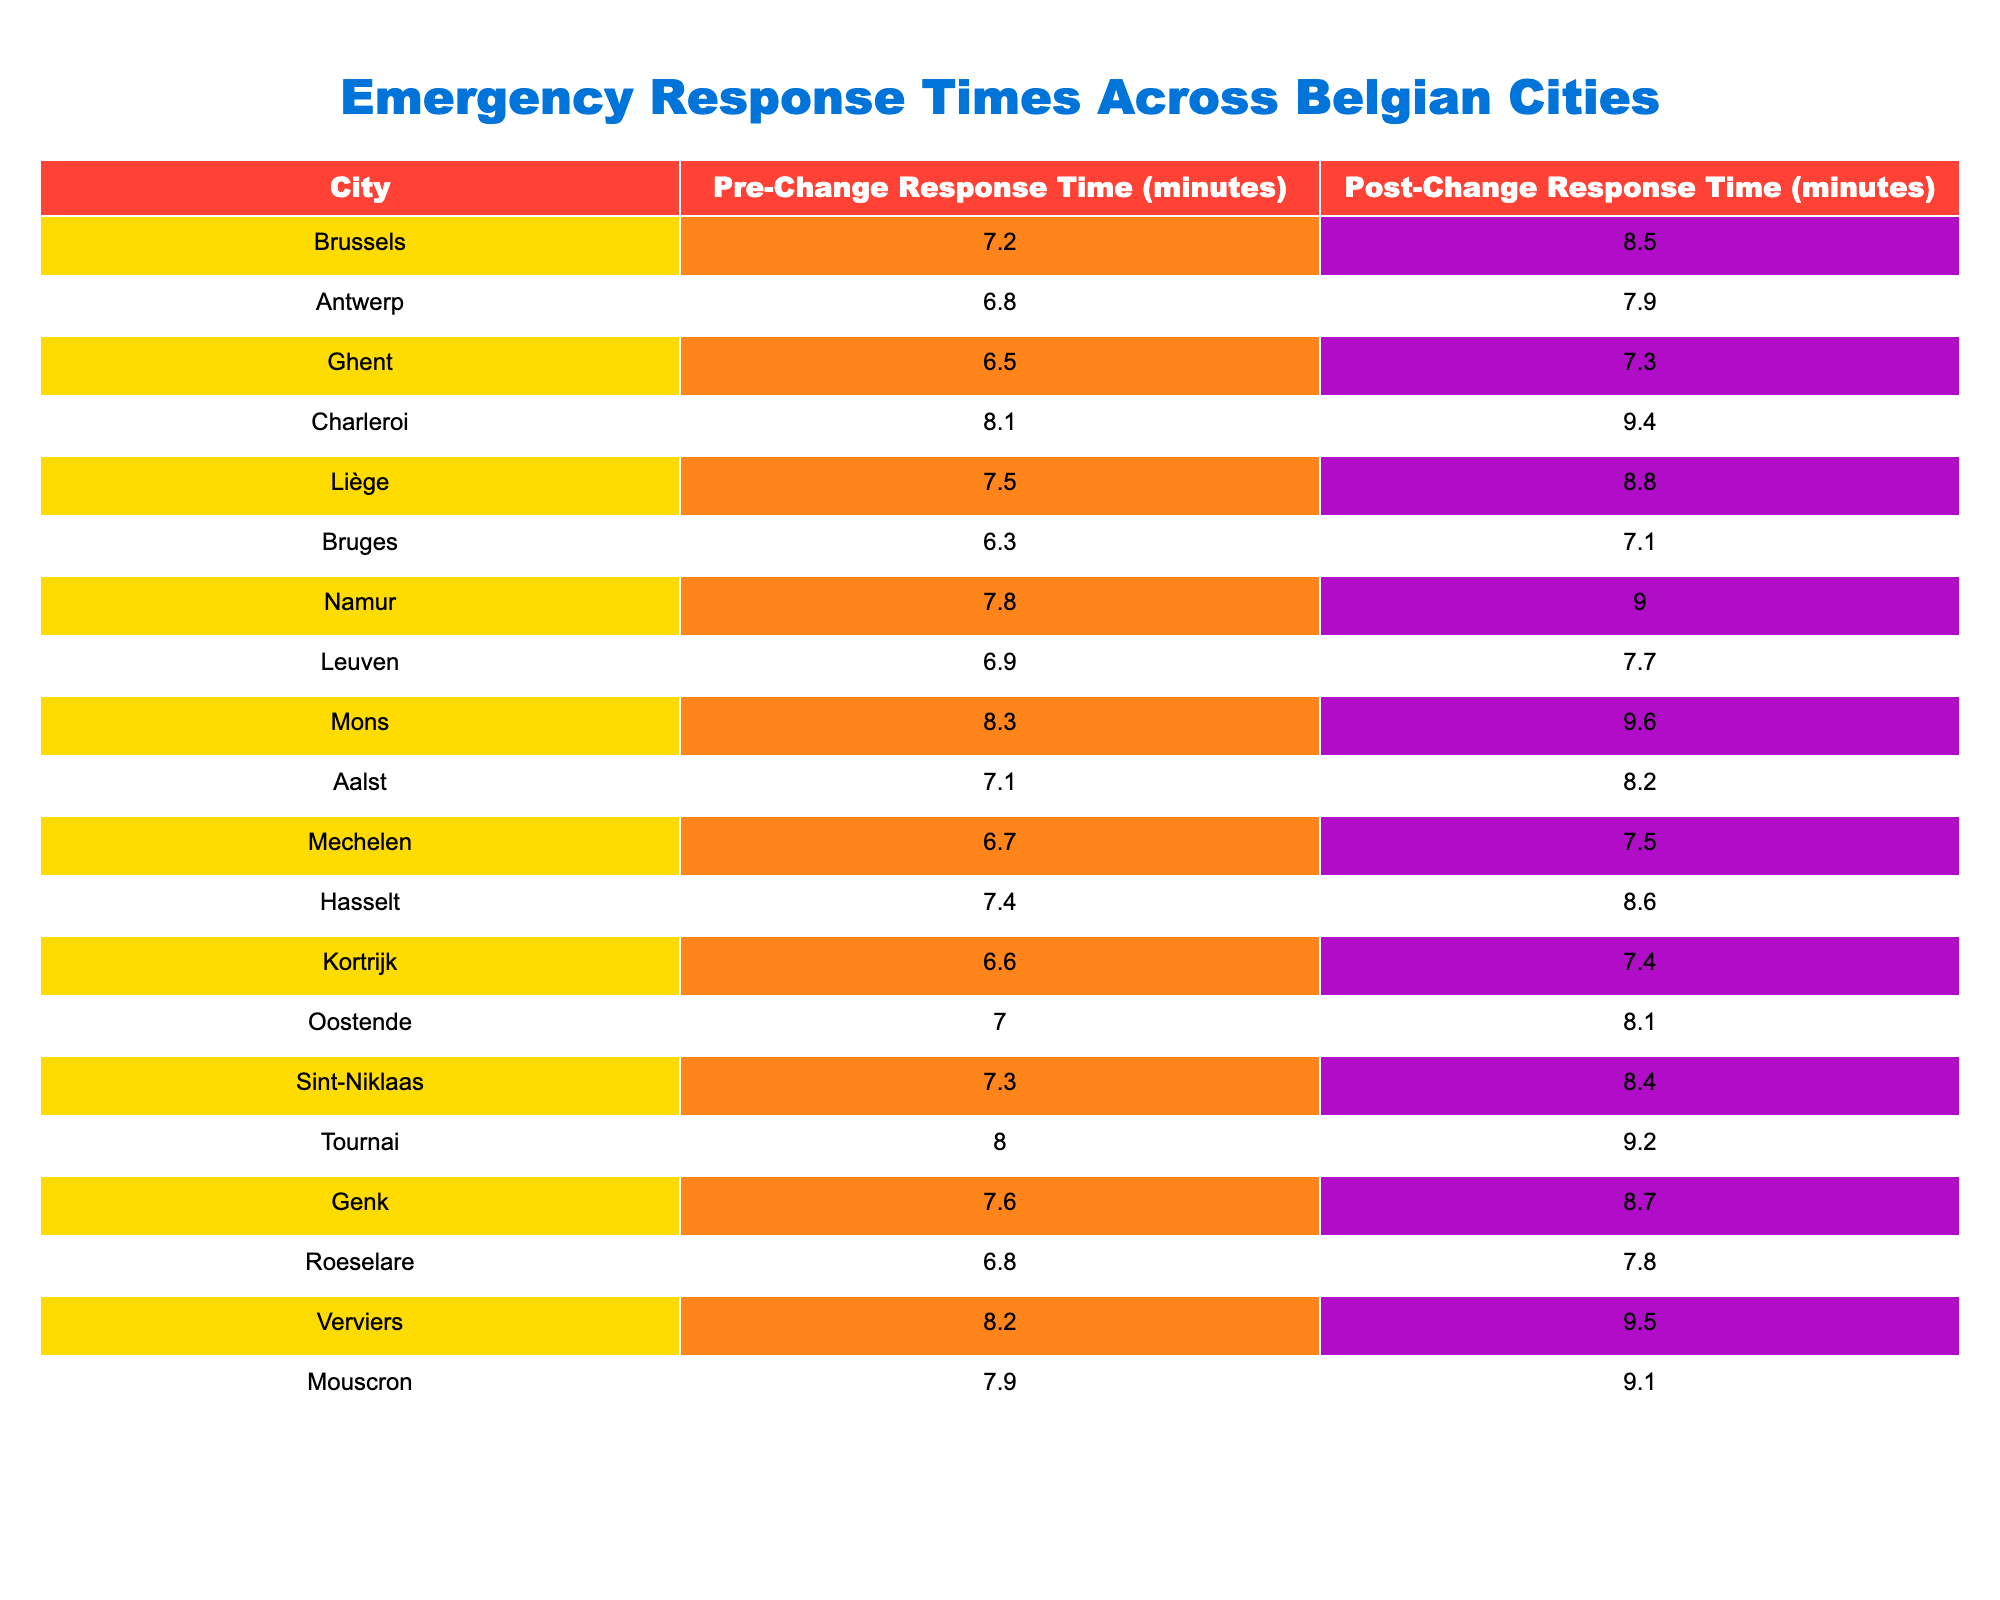What is the response time in Ghent before the changes? The table provides the data for Ghent's pre-change response time, which is directly listed in the relevant column. Ghent's pre-change response time is 6.5 minutes.
Answer: 6.5 What city had the highest post-change response time? By comparing the post-change response times of all cities in the table, Charleroi has the highest response time at 9.4 minutes.
Answer: Charleroi What is the difference in response times for Antwerp before and after the changes? The pre-change response time for Antwerp is 6.8 minutes, and the post-change response time is 7.9 minutes. The difference is calculated as 7.9 - 6.8 = 1.1 minutes.
Answer: 1.1 Is the post-change response time in Leuven higher than the pre-change response time? By checking both values for Leuven, the pre-change response time is 6.9 minutes and the post-change is 7.7 minutes. Since 7.7 is greater than 6.9, the response is yes.
Answer: Yes What is the average post-change response time across all cities? To find the average, sum all the post-change response times: (8.5 + 7.9 + 7.3 + 9.4 + 8.8 + 7.1 + 9.0 + 7.7 + 9.6 + 8.2 + 7.5 + 8.6 + 7.4 + 8.1 + 8.4 + 9.2 + 8.7 + 7.8 + 9.5 + 9.1) = 169.7. There are 20 cities, so the average is 169.7 / 20 = 8.485 minutes.
Answer: 8.485 Which city had the smallest increase in response time? By examining the change for each city: the smallest increase is in Bruges, which had a pre-change time of 6.3 minutes and a post-change time of 7.1 minutes, giving an increase of 0.8 minutes.
Answer: Bruges Are there any cities where the post-change response time is less than 8 minutes? Review the post-change response times listed: Leuven (7.7), Bruges (7.1), and Aalst (8.2) are less than 8 minutes, confirming that there are cities with times below this threshold.
Answer: Yes What percentage increase in response time did Ghent experience after the changes? The pre-change response time for Ghent is 6.5 minutes and the post-change response time is 7.3 minutes. The increase is 7.3 - 6.5 = 0.8 minutes. The percentage increase is (0.8 / 6.5) * 100 = 12.31%.
Answer: 12.31% How many cities have a post-change response time greater than 9 minutes? Checking all post-change response times, the cities with times over 9 minutes are Charleroi, Namur, Mons, and Verviers, totaling 4 cities.
Answer: 4 What is the relationship between the pre-change response times and the post-change response times in Hasselt and Roeselare? For Hasselt, the pre-change is 7.4 and post-change is 8.6, showing an increase of 1.2. For Roeselare, pre-change is 6.8 and post-change is 7.8, which is an increase of 1.0. Hasselt has a greater increase than Roeselare.
Answer: Hasselt has a greater increase What was the overall trend in emergency response times across Belgian cities after the system changes? By analyzing all the cities, it is clear that every city experienced an increase in response time from pre-change to post-change, indicating a negative trend in emergency response efficiency.
Answer: Increase for all cities 